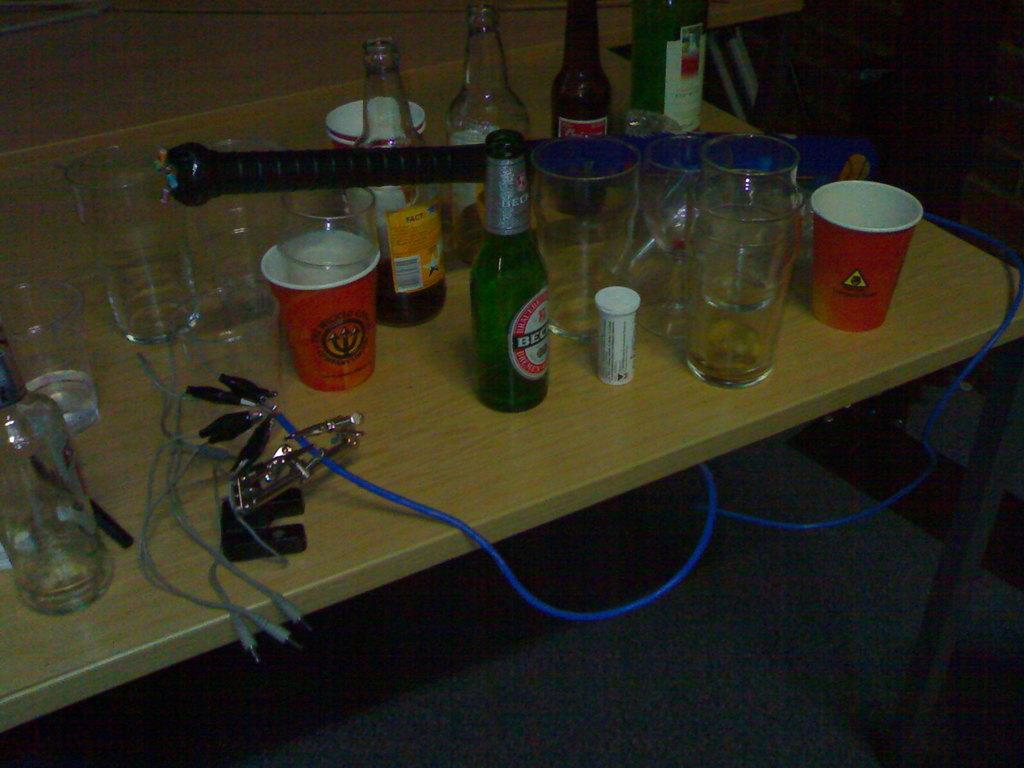What piece of furniture is present in the image? There is a table in the image. What objects are placed on the table? There are glasses and beer bottles on the table. What additional item can be seen on the table? There is a baseball bat with wires on the table. How many rabbits are hopping across the stage in the image? There are no rabbits or stage present in the image. What type of gate can be seen in the image? There is no gate present in the image. 